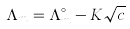<formula> <loc_0><loc_0><loc_500><loc_500>\Lambda _ { m } = \Lambda _ { m } ^ { \circ } - K \sqrt { c }</formula> 